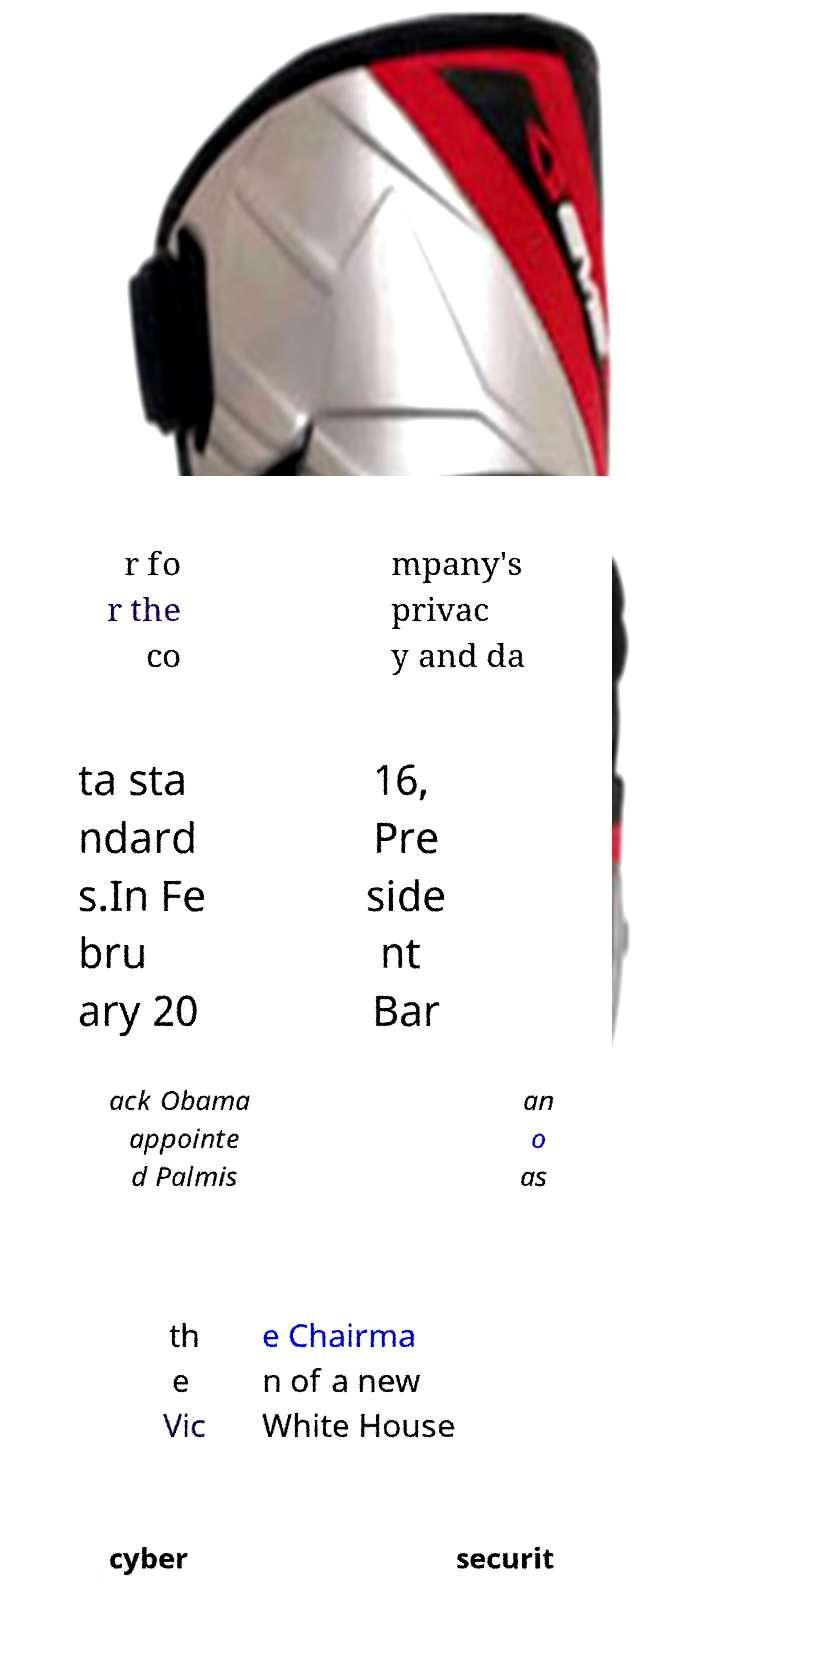Can you accurately transcribe the text from the provided image for me? r fo r the co mpany's privac y and da ta sta ndard s.In Fe bru ary 20 16, Pre side nt Bar ack Obama appointe d Palmis an o as th e Vic e Chairma n of a new White House cyber securit 